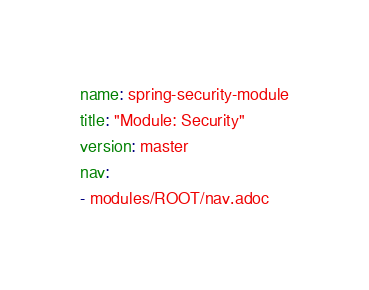<code> <loc_0><loc_0><loc_500><loc_500><_YAML_>name: spring-security-module
title: "Module: Security"
version: master
nav:
- modules/ROOT/nav.adoc
</code> 